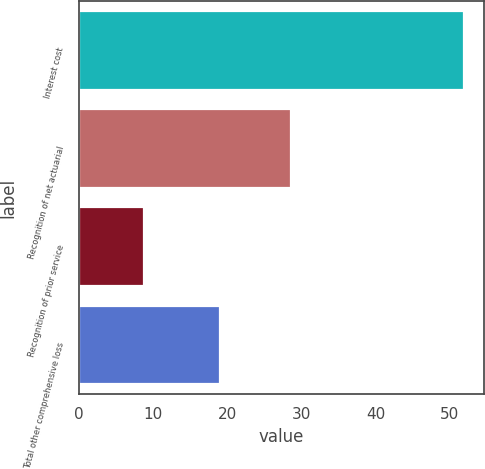<chart> <loc_0><loc_0><loc_500><loc_500><bar_chart><fcel>Interest cost<fcel>Recognition of net actuarial<fcel>Recognition of prior service<fcel>Total other comprehensive loss<nl><fcel>52<fcel>28.6<fcel>8.8<fcel>19<nl></chart> 